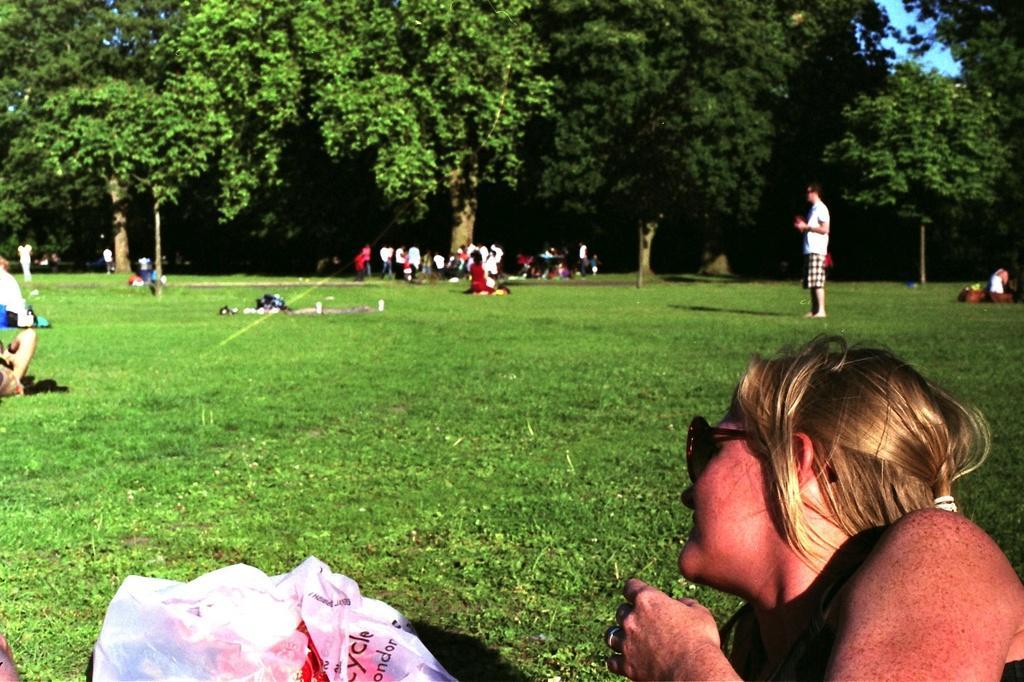Can you describe this image briefly? At the bottom of the image there is a lady and also there is a plastic bag. There is grass on the ground and also there are many people. In the background there are trees.  